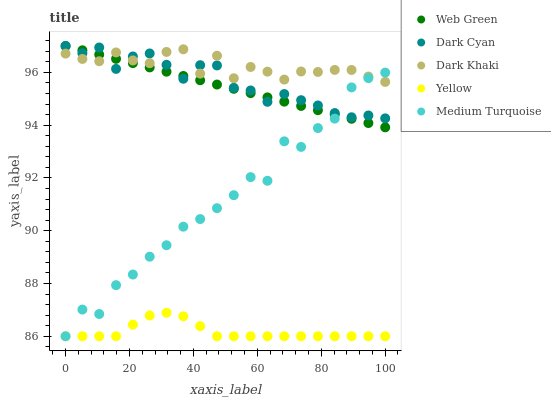Does Yellow have the minimum area under the curve?
Answer yes or no. Yes. Does Dark Khaki have the maximum area under the curve?
Answer yes or no. Yes. Does Medium Turquoise have the minimum area under the curve?
Answer yes or no. No. Does Medium Turquoise have the maximum area under the curve?
Answer yes or no. No. Is Web Green the smoothest?
Answer yes or no. Yes. Is Medium Turquoise the roughest?
Answer yes or no. Yes. Is Dark Khaki the smoothest?
Answer yes or no. No. Is Dark Khaki the roughest?
Answer yes or no. No. Does Medium Turquoise have the lowest value?
Answer yes or no. Yes. Does Dark Khaki have the lowest value?
Answer yes or no. No. Does Web Green have the highest value?
Answer yes or no. Yes. Does Dark Khaki have the highest value?
Answer yes or no. No. Is Yellow less than Dark Cyan?
Answer yes or no. Yes. Is Dark Khaki greater than Yellow?
Answer yes or no. Yes. Does Dark Cyan intersect Dark Khaki?
Answer yes or no. Yes. Is Dark Cyan less than Dark Khaki?
Answer yes or no. No. Is Dark Cyan greater than Dark Khaki?
Answer yes or no. No. Does Yellow intersect Dark Cyan?
Answer yes or no. No. 